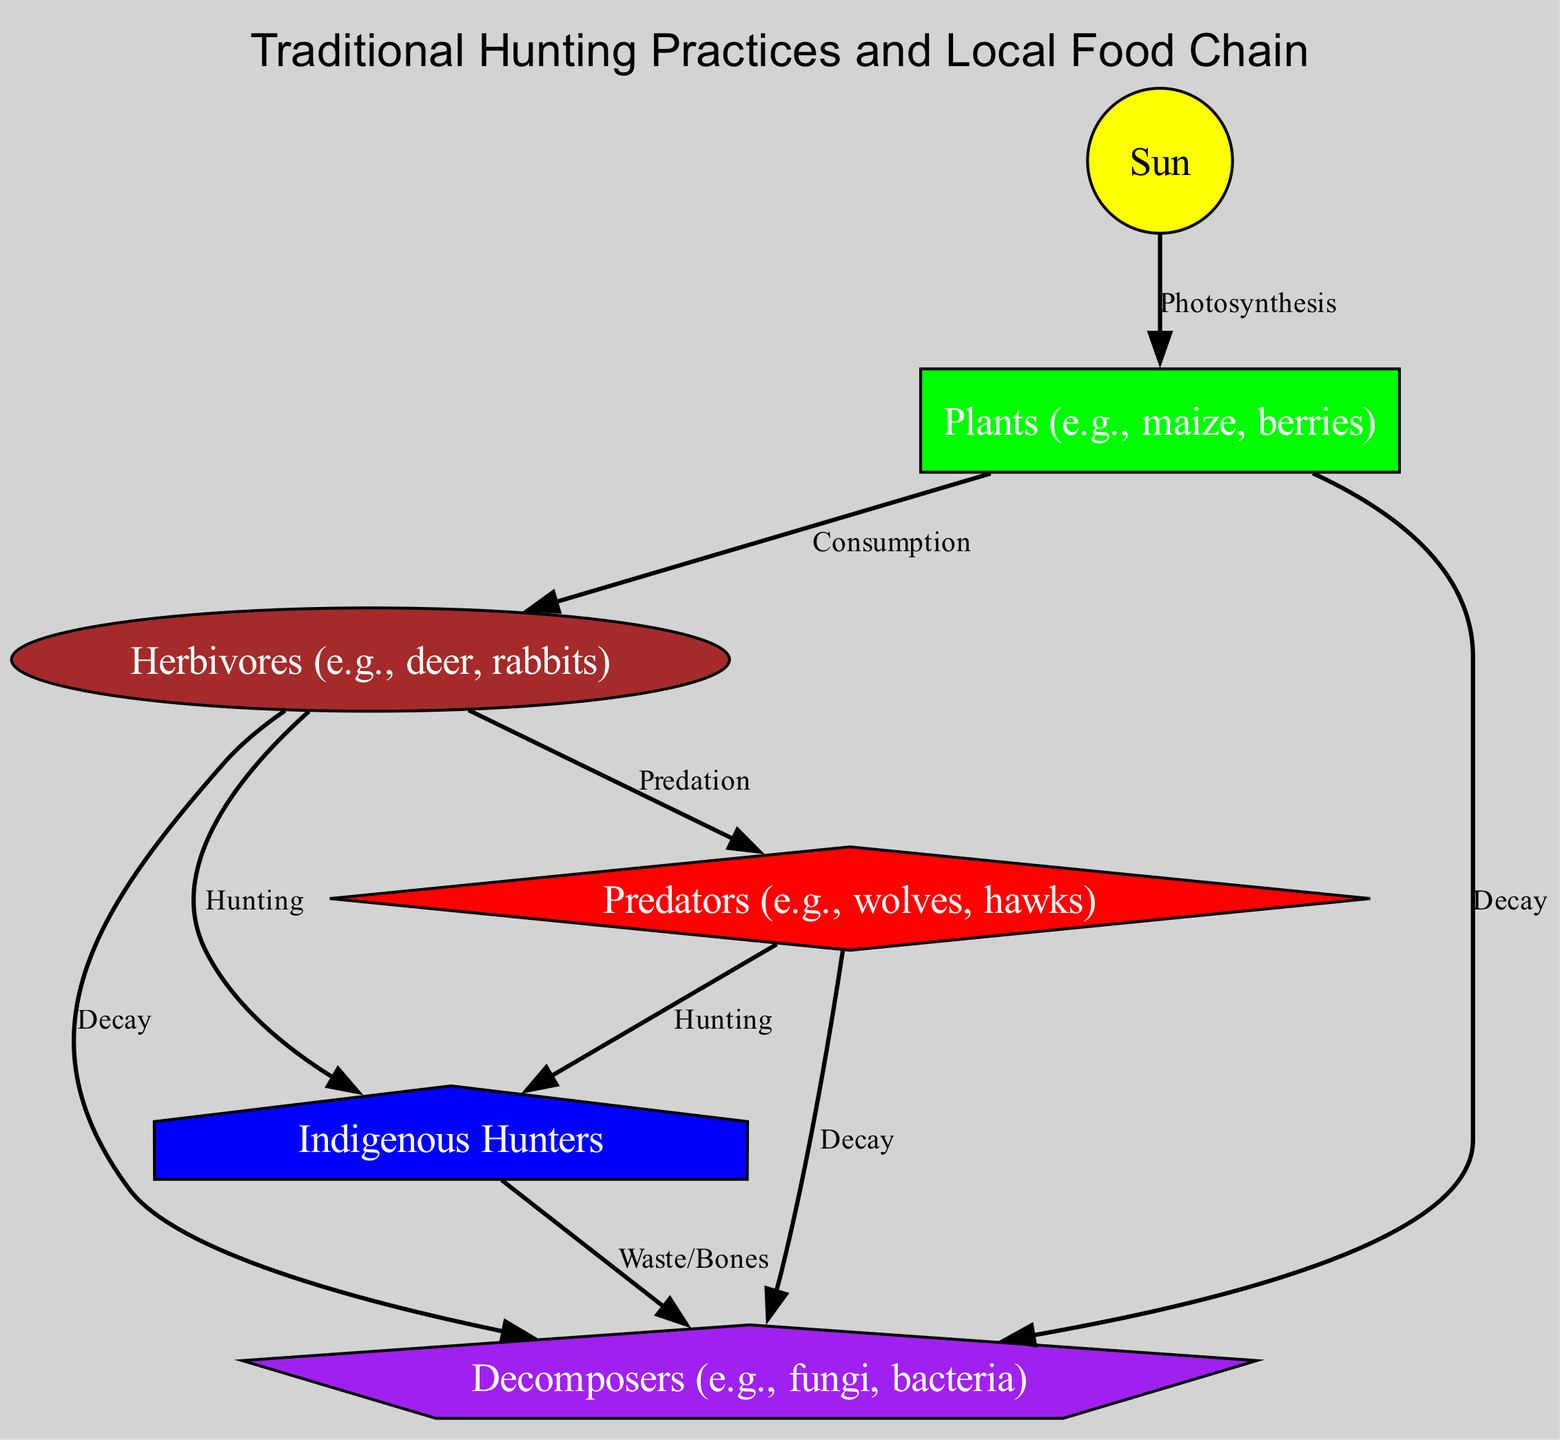What is the first node in the food chain? The diagram starts with the "Sun" node, which is the primary energy source for the food chain. It is positioned at the top, indicating it is the first element in the food chain hierarchy.
Answer: Sun How many herbivores are depicted in the diagram? The diagram shows one herbivore node, labeled "Herbivores (e.g., deer, rabbits)," indicating that there is one type of herbivore represented in the food chain.
Answer: 1 Which node do herbivores consume? According to the diagram, herbivores consume "Plants (e.g., maize, berries)." The edge labeled "Consumption" directly connects "plants" to "herbivores."
Answer: Plants (e.g., maize, berries) What do Indigenous Hunters hunt according to the diagram? The diagram indicates that Indigenous Hunters hunt both "Herbivores" and "Predators." There are two separate edges labeled "Hunting," which connect "herbivores" and "predators" to "humans."
Answer: Herbivores and Predators What role do decomposers play in the food chain? Decomposers break down organic matter in the diagram. They are connected to "humans," "plants," "herbivores," and "predators" through various edges labeled "Waste/Bones" and "Decay," indicating their role in recycling nutrients in the ecosystem.
Answer: Recycling nutrients How many types of relationships are depicted between the nodes? The diagram shows six edges connecting the various nodes, representing different relationships in the food chain such as "Photosynthesis," "Consumption," "Predation," "Hunting," and "Decay."
Answer: 6 Which node represents the primary producers in the food chain? The "Plants (e.g., maize, berries)" node represents the primary producers in the food chain, as it is the first consumer of the sun's energy through photosynthesis.
Answer: Plants (e.g., maize, berries) What happens to the remains of hunted animals according to the diagram? The diagram illustrates that the remains of hunted animals, represented by the "Waste/Bones" edge, are decomposed by "Decomposers." This indicates that waste from indigenous hunters contributes to nutrient cycling.
Answer: Decomposed by Decomposers Which node is directly connected to the Sun? The "Plants (e.g., maize, berries)" node is directly connected to the "Sun" node through the edge labeled "Photosynthesis," indicating the first step in the food chain.
Answer: Plants (e.g., maize, berries) 